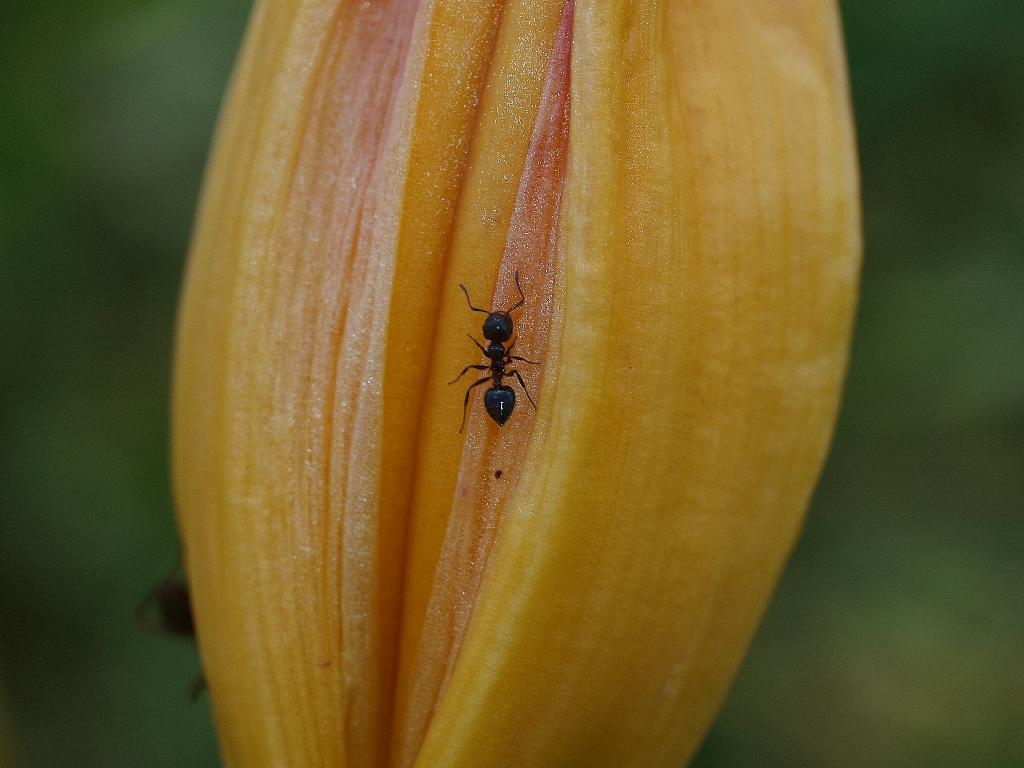What is the color of the insert on the bus in the image? The insert on the bus in the image is yellow. What type of vehicle is the insert attached to? The insert is attached to a bus. Is there a woman in the image who is experiencing a loss of appetite due to food poisoning? There is no information about a woman or food poisoning in the image, so we cannot answer that question. 